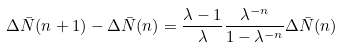Convert formula to latex. <formula><loc_0><loc_0><loc_500><loc_500>\Delta \bar { N } ( n + 1 ) - \Delta \bar { N } ( n ) = \frac { \lambda - 1 } { \lambda } \frac { \lambda ^ { - n } } { 1 - \lambda ^ { - n } } \Delta \bar { N } ( n )</formula> 